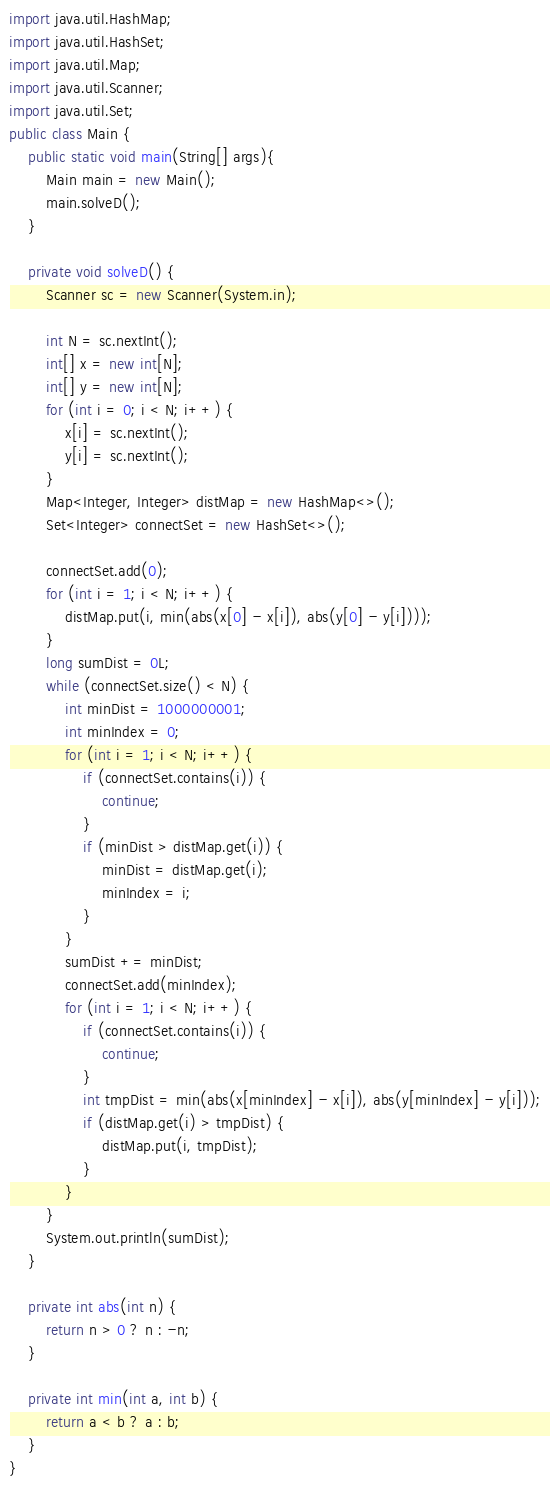<code> <loc_0><loc_0><loc_500><loc_500><_Java_>import java.util.HashMap;
import java.util.HashSet;
import java.util.Map;
import java.util.Scanner;
import java.util.Set;
public class Main {
	public static void main(String[] args){
		Main main = new Main();
		main.solveD();
	}

	private void solveD() {
		Scanner sc = new Scanner(System.in);

		int N = sc.nextInt();
		int[] x = new int[N];
		int[] y = new int[N];
		for (int i = 0; i < N; i++) {
			x[i] = sc.nextInt();
			y[i] = sc.nextInt();
		}
		Map<Integer, Integer> distMap = new HashMap<>();
		Set<Integer> connectSet = new HashSet<>();
		
		connectSet.add(0);
		for (int i = 1; i < N; i++) {
			distMap.put(i, min(abs(x[0] - x[i]), abs(y[0] - y[i])));
		}
		long sumDist = 0L;
		while (connectSet.size() < N) {
			int minDist = 1000000001;
			int minIndex = 0;
			for (int i = 1; i < N; i++) {
				if (connectSet.contains(i)) {
					continue;
				}
				if (minDist > distMap.get(i)) {
					minDist = distMap.get(i);
					minIndex = i;
				}
			}
			sumDist += minDist;
			connectSet.add(minIndex);
			for (int i = 1; i < N; i++) {
				if (connectSet.contains(i)) {
					continue;
				}
				int tmpDist = min(abs(x[minIndex] - x[i]), abs(y[minIndex] - y[i]));
				if (distMap.get(i) > tmpDist) {
					distMap.put(i, tmpDist);
				}
			}
		}
		System.out.println(sumDist);
	}

	private int abs(int n) {
		return n > 0 ? n : -n;
	}

	private int min(int a, int b) {
		return a < b ? a : b;
	}
}</code> 